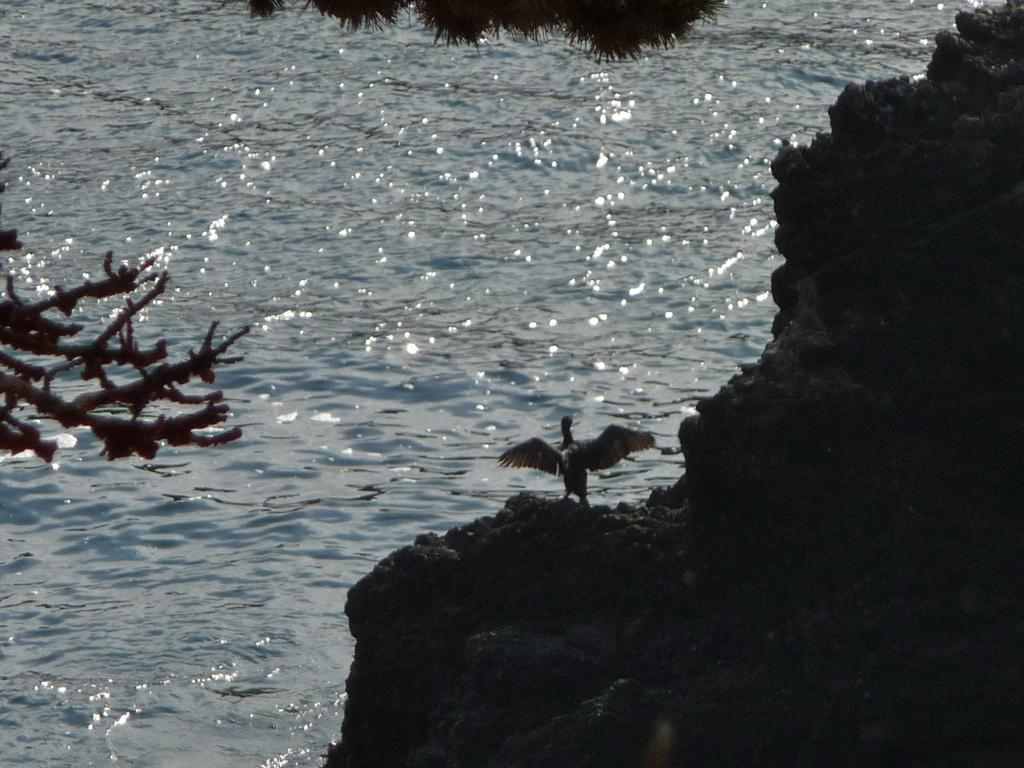What type of body of water is present in the image? There is a lake in the image. Can you describe the vegetation or ground cover in the image? There might be grass at the top of the image. What is happening on the left side of the image? There are birds flying on the left side of the image. What geographical feature is on the right side of the image? There is a hill on the right side of the image. Is there any wildlife on the hill? Yes, there is a bird on the hill. What type of fruit is hanging from the trees near the lake in the image? There are no trees or fruit mentioned in the image; it only a lake, birds, a hill, and grass are described. 